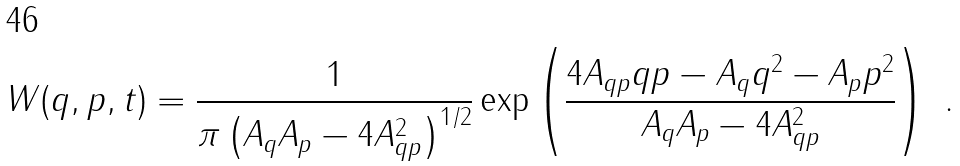Convert formula to latex. <formula><loc_0><loc_0><loc_500><loc_500>W ( q , p , t ) = \frac { 1 } { \pi \left ( A _ { q } A _ { p } - 4 A _ { q p } ^ { 2 } \right ) ^ { 1 / 2 } } \exp \left ( \frac { 4 A _ { q p } q p - A _ { q } q ^ { 2 } - A _ { p } p ^ { 2 } } { A _ { q } A _ { p } - 4 A _ { q p } ^ { 2 } } \right ) \ .</formula> 